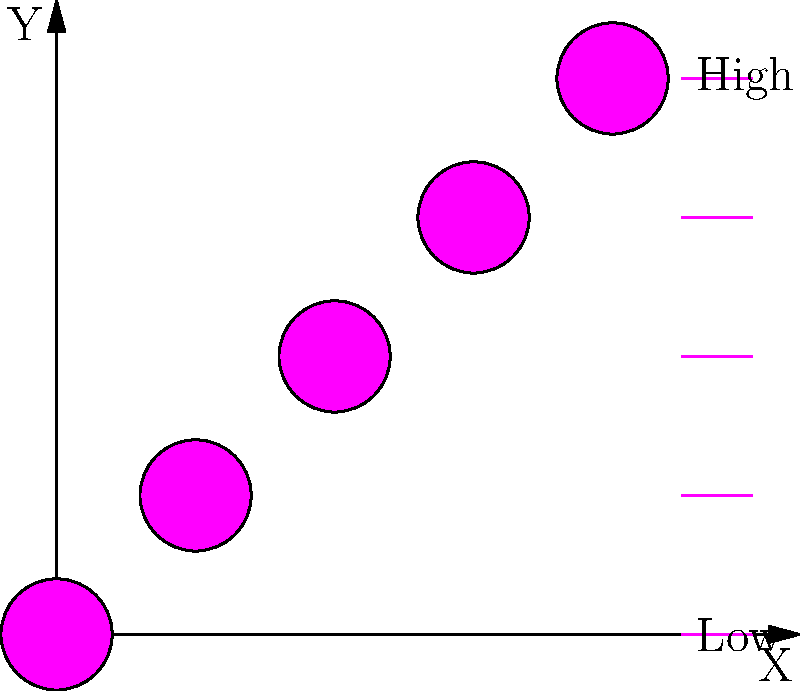Based on the heat map depicting crime distribution in an urban area, what pattern of criminal activity does this visualization suggest, and how might this information inform targeted crime prevention strategies? To analyze this heat map and its implications for crime prevention strategies, let's break it down step-by-step:

1. Heat Map Interpretation:
   - The map shows a diagonal pattern from the bottom-left to the top-right.
   - Colors range from cool (blue) to hot (red), indicating increasing crime intensity.

2. Spatial Distribution:
   - There's a clear gradient of criminal activity from the southwest to the northeast of the mapped area.
   - The southwest corner (0,0) shows the lowest crime rate (blue).
   - The northeast corner (4,4) shows the highest crime rate (red).

3. Pattern Analysis:
   - This pattern suggests a correlation between geographic location and crime rate.
   - It could indicate a socioeconomic gradient, with more affluent areas in the southwest and less affluent areas in the northeast.

4. Potential Factors:
   - Socioeconomic status: Higher crime rates often correlate with lower income areas.
   - Urban development: The pattern might reflect differences in urban planning and infrastructure.
   - Population density: More densely populated areas often experience higher crime rates.

5. Implications for Crime Prevention:
   - Targeted patrols: Increase police presence in high-crime (red) areas.
   - Community programs: Implement social programs in transitional (yellow/orange) areas to prevent further deterioration.
   - Urban planning: Improve infrastructure and living conditions in high-crime areas.
   - Economic development: Focus on job creation and economic opportunities in the northeast region.

6. Data-Driven Approach:
   - Use this visualization to allocate resources more effectively.
   - Monitor changes over time to assess the impact of implemented strategies.

7. Investigative Focus:
   - As an investigative journalist, explore the underlying causes of this spatial distribution.
   - Investigate potential links between crime rates and specific socioeconomic factors in different areas.
Answer: The heat map suggests a diagonal gradient of increasing criminal activity from southwest to northeast, likely reflecting socioeconomic disparities. This informs targeted strategies such as increased policing in high-crime areas, community programs in transitional zones, and economic development initiatives in the northeast region. 